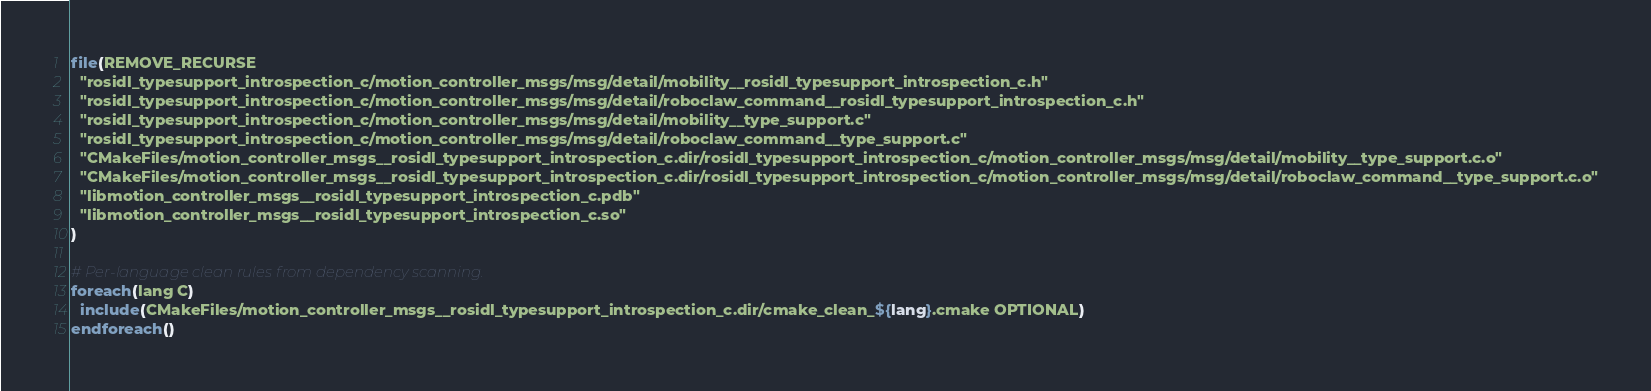<code> <loc_0><loc_0><loc_500><loc_500><_CMake_>file(REMOVE_RECURSE
  "rosidl_typesupport_introspection_c/motion_controller_msgs/msg/detail/mobility__rosidl_typesupport_introspection_c.h"
  "rosidl_typesupport_introspection_c/motion_controller_msgs/msg/detail/roboclaw_command__rosidl_typesupport_introspection_c.h"
  "rosidl_typesupport_introspection_c/motion_controller_msgs/msg/detail/mobility__type_support.c"
  "rosidl_typesupport_introspection_c/motion_controller_msgs/msg/detail/roboclaw_command__type_support.c"
  "CMakeFiles/motion_controller_msgs__rosidl_typesupport_introspection_c.dir/rosidl_typesupport_introspection_c/motion_controller_msgs/msg/detail/mobility__type_support.c.o"
  "CMakeFiles/motion_controller_msgs__rosidl_typesupport_introspection_c.dir/rosidl_typesupport_introspection_c/motion_controller_msgs/msg/detail/roboclaw_command__type_support.c.o"
  "libmotion_controller_msgs__rosidl_typesupport_introspection_c.pdb"
  "libmotion_controller_msgs__rosidl_typesupport_introspection_c.so"
)

# Per-language clean rules from dependency scanning.
foreach(lang C)
  include(CMakeFiles/motion_controller_msgs__rosidl_typesupport_introspection_c.dir/cmake_clean_${lang}.cmake OPTIONAL)
endforeach()
</code> 